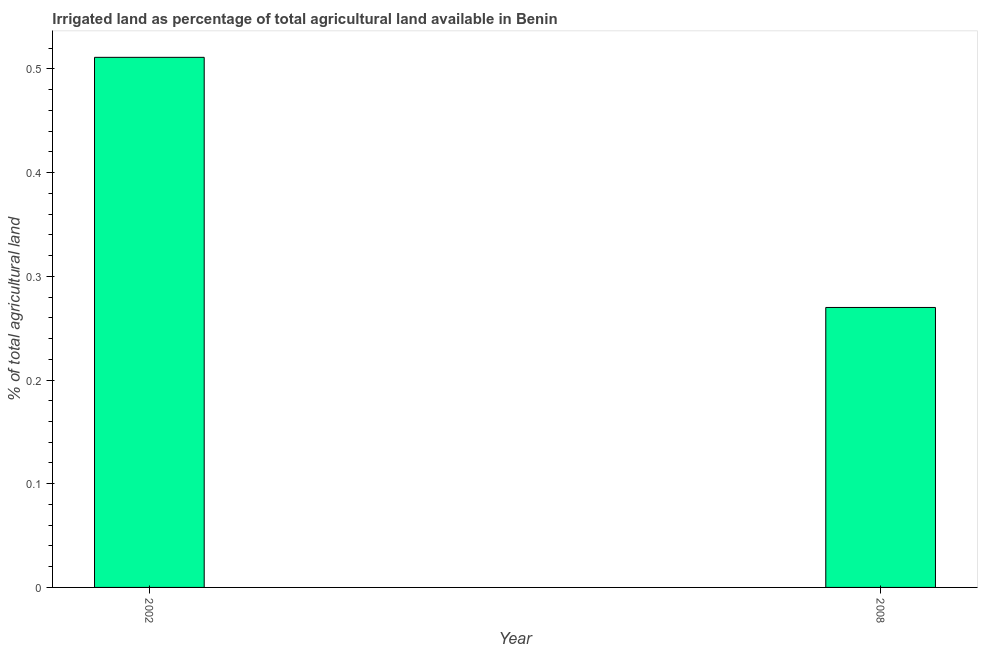Does the graph contain grids?
Keep it short and to the point. No. What is the title of the graph?
Offer a very short reply. Irrigated land as percentage of total agricultural land available in Benin. What is the label or title of the Y-axis?
Offer a very short reply. % of total agricultural land. What is the percentage of agricultural irrigated land in 2002?
Make the answer very short. 0.51. Across all years, what is the maximum percentage of agricultural irrigated land?
Make the answer very short. 0.51. Across all years, what is the minimum percentage of agricultural irrigated land?
Offer a very short reply. 0.27. In which year was the percentage of agricultural irrigated land maximum?
Keep it short and to the point. 2002. What is the sum of the percentage of agricultural irrigated land?
Your answer should be very brief. 0.78. What is the difference between the percentage of agricultural irrigated land in 2002 and 2008?
Your response must be concise. 0.24. What is the average percentage of agricultural irrigated land per year?
Provide a succinct answer. 0.39. What is the median percentage of agricultural irrigated land?
Provide a succinct answer. 0.39. What is the ratio of the percentage of agricultural irrigated land in 2002 to that in 2008?
Your answer should be very brief. 1.89. Is the percentage of agricultural irrigated land in 2002 less than that in 2008?
Provide a succinct answer. No. How many bars are there?
Your answer should be very brief. 2. What is the % of total agricultural land in 2002?
Give a very brief answer. 0.51. What is the % of total agricultural land of 2008?
Make the answer very short. 0.27. What is the difference between the % of total agricultural land in 2002 and 2008?
Give a very brief answer. 0.24. What is the ratio of the % of total agricultural land in 2002 to that in 2008?
Your answer should be very brief. 1.89. 